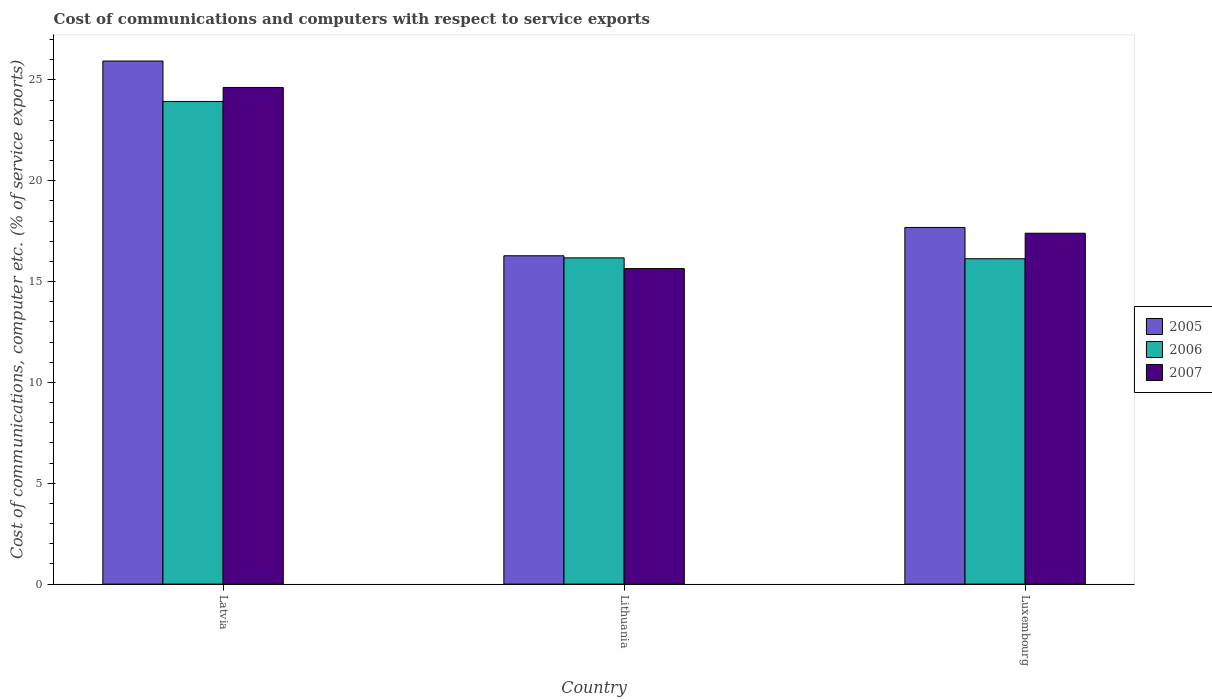Are the number of bars on each tick of the X-axis equal?
Ensure brevity in your answer.  Yes. How many bars are there on the 2nd tick from the left?
Your response must be concise. 3. What is the label of the 3rd group of bars from the left?
Provide a short and direct response. Luxembourg. In how many cases, is the number of bars for a given country not equal to the number of legend labels?
Offer a terse response. 0. What is the cost of communications and computers in 2005 in Latvia?
Your answer should be very brief. 25.94. Across all countries, what is the maximum cost of communications and computers in 2007?
Your answer should be very brief. 24.62. Across all countries, what is the minimum cost of communications and computers in 2007?
Your answer should be very brief. 15.64. In which country was the cost of communications and computers in 2006 maximum?
Your answer should be very brief. Latvia. In which country was the cost of communications and computers in 2005 minimum?
Your response must be concise. Lithuania. What is the total cost of communications and computers in 2006 in the graph?
Offer a very short reply. 56.24. What is the difference between the cost of communications and computers in 2007 in Latvia and that in Lithuania?
Make the answer very short. 8.98. What is the difference between the cost of communications and computers in 2006 in Latvia and the cost of communications and computers in 2007 in Lithuania?
Provide a short and direct response. 8.29. What is the average cost of communications and computers in 2005 per country?
Offer a very short reply. 19.97. What is the difference between the cost of communications and computers of/in 2006 and cost of communications and computers of/in 2005 in Latvia?
Your answer should be very brief. -2. In how many countries, is the cost of communications and computers in 2005 greater than 13 %?
Ensure brevity in your answer.  3. What is the ratio of the cost of communications and computers in 2007 in Lithuania to that in Luxembourg?
Offer a terse response. 0.9. What is the difference between the highest and the second highest cost of communications and computers in 2006?
Your answer should be compact. 0.04. What is the difference between the highest and the lowest cost of communications and computers in 2005?
Ensure brevity in your answer.  9.66. In how many countries, is the cost of communications and computers in 2006 greater than the average cost of communications and computers in 2006 taken over all countries?
Provide a succinct answer. 1. What does the 2nd bar from the right in Lithuania represents?
Ensure brevity in your answer.  2006. Is it the case that in every country, the sum of the cost of communications and computers in 2006 and cost of communications and computers in 2005 is greater than the cost of communications and computers in 2007?
Provide a short and direct response. Yes. What is the difference between two consecutive major ticks on the Y-axis?
Offer a terse response. 5. Are the values on the major ticks of Y-axis written in scientific E-notation?
Keep it short and to the point. No. Does the graph contain any zero values?
Your response must be concise. No. Does the graph contain grids?
Your response must be concise. No. Where does the legend appear in the graph?
Your answer should be compact. Center right. How many legend labels are there?
Provide a short and direct response. 3. How are the legend labels stacked?
Provide a succinct answer. Vertical. What is the title of the graph?
Offer a very short reply. Cost of communications and computers with respect to service exports. Does "1992" appear as one of the legend labels in the graph?
Ensure brevity in your answer.  No. What is the label or title of the X-axis?
Keep it short and to the point. Country. What is the label or title of the Y-axis?
Your answer should be compact. Cost of communications, computer etc. (% of service exports). What is the Cost of communications, computer etc. (% of service exports) in 2005 in Latvia?
Make the answer very short. 25.94. What is the Cost of communications, computer etc. (% of service exports) of 2006 in Latvia?
Offer a terse response. 23.93. What is the Cost of communications, computer etc. (% of service exports) in 2007 in Latvia?
Your response must be concise. 24.62. What is the Cost of communications, computer etc. (% of service exports) in 2005 in Lithuania?
Ensure brevity in your answer.  16.28. What is the Cost of communications, computer etc. (% of service exports) of 2006 in Lithuania?
Offer a very short reply. 16.18. What is the Cost of communications, computer etc. (% of service exports) in 2007 in Lithuania?
Offer a terse response. 15.64. What is the Cost of communications, computer etc. (% of service exports) in 2005 in Luxembourg?
Offer a very short reply. 17.68. What is the Cost of communications, computer etc. (% of service exports) of 2006 in Luxembourg?
Offer a very short reply. 16.13. What is the Cost of communications, computer etc. (% of service exports) in 2007 in Luxembourg?
Ensure brevity in your answer.  17.4. Across all countries, what is the maximum Cost of communications, computer etc. (% of service exports) in 2005?
Your answer should be very brief. 25.94. Across all countries, what is the maximum Cost of communications, computer etc. (% of service exports) of 2006?
Keep it short and to the point. 23.93. Across all countries, what is the maximum Cost of communications, computer etc. (% of service exports) in 2007?
Ensure brevity in your answer.  24.62. Across all countries, what is the minimum Cost of communications, computer etc. (% of service exports) in 2005?
Ensure brevity in your answer.  16.28. Across all countries, what is the minimum Cost of communications, computer etc. (% of service exports) in 2006?
Make the answer very short. 16.13. Across all countries, what is the minimum Cost of communications, computer etc. (% of service exports) of 2007?
Make the answer very short. 15.64. What is the total Cost of communications, computer etc. (% of service exports) of 2005 in the graph?
Give a very brief answer. 59.9. What is the total Cost of communications, computer etc. (% of service exports) of 2006 in the graph?
Offer a very short reply. 56.24. What is the total Cost of communications, computer etc. (% of service exports) in 2007 in the graph?
Give a very brief answer. 57.67. What is the difference between the Cost of communications, computer etc. (% of service exports) of 2005 in Latvia and that in Lithuania?
Offer a terse response. 9.66. What is the difference between the Cost of communications, computer etc. (% of service exports) of 2006 in Latvia and that in Lithuania?
Your answer should be compact. 7.76. What is the difference between the Cost of communications, computer etc. (% of service exports) in 2007 in Latvia and that in Lithuania?
Your answer should be compact. 8.98. What is the difference between the Cost of communications, computer etc. (% of service exports) in 2005 in Latvia and that in Luxembourg?
Ensure brevity in your answer.  8.25. What is the difference between the Cost of communications, computer etc. (% of service exports) of 2006 in Latvia and that in Luxembourg?
Ensure brevity in your answer.  7.8. What is the difference between the Cost of communications, computer etc. (% of service exports) in 2007 in Latvia and that in Luxembourg?
Your answer should be very brief. 7.23. What is the difference between the Cost of communications, computer etc. (% of service exports) in 2005 in Lithuania and that in Luxembourg?
Your answer should be very brief. -1.4. What is the difference between the Cost of communications, computer etc. (% of service exports) in 2006 in Lithuania and that in Luxembourg?
Provide a succinct answer. 0.04. What is the difference between the Cost of communications, computer etc. (% of service exports) in 2007 in Lithuania and that in Luxembourg?
Offer a very short reply. -1.75. What is the difference between the Cost of communications, computer etc. (% of service exports) of 2005 in Latvia and the Cost of communications, computer etc. (% of service exports) of 2006 in Lithuania?
Your response must be concise. 9.76. What is the difference between the Cost of communications, computer etc. (% of service exports) of 2005 in Latvia and the Cost of communications, computer etc. (% of service exports) of 2007 in Lithuania?
Provide a short and direct response. 10.29. What is the difference between the Cost of communications, computer etc. (% of service exports) in 2006 in Latvia and the Cost of communications, computer etc. (% of service exports) in 2007 in Lithuania?
Offer a terse response. 8.29. What is the difference between the Cost of communications, computer etc. (% of service exports) of 2005 in Latvia and the Cost of communications, computer etc. (% of service exports) of 2006 in Luxembourg?
Your answer should be very brief. 9.8. What is the difference between the Cost of communications, computer etc. (% of service exports) of 2005 in Latvia and the Cost of communications, computer etc. (% of service exports) of 2007 in Luxembourg?
Keep it short and to the point. 8.54. What is the difference between the Cost of communications, computer etc. (% of service exports) of 2006 in Latvia and the Cost of communications, computer etc. (% of service exports) of 2007 in Luxembourg?
Your answer should be compact. 6.53. What is the difference between the Cost of communications, computer etc. (% of service exports) of 2005 in Lithuania and the Cost of communications, computer etc. (% of service exports) of 2006 in Luxembourg?
Your response must be concise. 0.15. What is the difference between the Cost of communications, computer etc. (% of service exports) of 2005 in Lithuania and the Cost of communications, computer etc. (% of service exports) of 2007 in Luxembourg?
Keep it short and to the point. -1.12. What is the difference between the Cost of communications, computer etc. (% of service exports) of 2006 in Lithuania and the Cost of communications, computer etc. (% of service exports) of 2007 in Luxembourg?
Offer a very short reply. -1.22. What is the average Cost of communications, computer etc. (% of service exports) of 2005 per country?
Your response must be concise. 19.97. What is the average Cost of communications, computer etc. (% of service exports) of 2006 per country?
Give a very brief answer. 18.75. What is the average Cost of communications, computer etc. (% of service exports) of 2007 per country?
Your answer should be compact. 19.22. What is the difference between the Cost of communications, computer etc. (% of service exports) of 2005 and Cost of communications, computer etc. (% of service exports) of 2006 in Latvia?
Offer a terse response. 2. What is the difference between the Cost of communications, computer etc. (% of service exports) in 2005 and Cost of communications, computer etc. (% of service exports) in 2007 in Latvia?
Offer a terse response. 1.31. What is the difference between the Cost of communications, computer etc. (% of service exports) in 2006 and Cost of communications, computer etc. (% of service exports) in 2007 in Latvia?
Your answer should be compact. -0.69. What is the difference between the Cost of communications, computer etc. (% of service exports) of 2005 and Cost of communications, computer etc. (% of service exports) of 2006 in Lithuania?
Provide a short and direct response. 0.1. What is the difference between the Cost of communications, computer etc. (% of service exports) in 2005 and Cost of communications, computer etc. (% of service exports) in 2007 in Lithuania?
Give a very brief answer. 0.64. What is the difference between the Cost of communications, computer etc. (% of service exports) of 2006 and Cost of communications, computer etc. (% of service exports) of 2007 in Lithuania?
Ensure brevity in your answer.  0.53. What is the difference between the Cost of communications, computer etc. (% of service exports) of 2005 and Cost of communications, computer etc. (% of service exports) of 2006 in Luxembourg?
Provide a succinct answer. 1.55. What is the difference between the Cost of communications, computer etc. (% of service exports) of 2005 and Cost of communications, computer etc. (% of service exports) of 2007 in Luxembourg?
Offer a very short reply. 0.29. What is the difference between the Cost of communications, computer etc. (% of service exports) in 2006 and Cost of communications, computer etc. (% of service exports) in 2007 in Luxembourg?
Ensure brevity in your answer.  -1.26. What is the ratio of the Cost of communications, computer etc. (% of service exports) in 2005 in Latvia to that in Lithuania?
Ensure brevity in your answer.  1.59. What is the ratio of the Cost of communications, computer etc. (% of service exports) of 2006 in Latvia to that in Lithuania?
Your answer should be compact. 1.48. What is the ratio of the Cost of communications, computer etc. (% of service exports) of 2007 in Latvia to that in Lithuania?
Ensure brevity in your answer.  1.57. What is the ratio of the Cost of communications, computer etc. (% of service exports) of 2005 in Latvia to that in Luxembourg?
Offer a very short reply. 1.47. What is the ratio of the Cost of communications, computer etc. (% of service exports) of 2006 in Latvia to that in Luxembourg?
Provide a short and direct response. 1.48. What is the ratio of the Cost of communications, computer etc. (% of service exports) of 2007 in Latvia to that in Luxembourg?
Make the answer very short. 1.42. What is the ratio of the Cost of communications, computer etc. (% of service exports) of 2005 in Lithuania to that in Luxembourg?
Give a very brief answer. 0.92. What is the ratio of the Cost of communications, computer etc. (% of service exports) in 2007 in Lithuania to that in Luxembourg?
Provide a short and direct response. 0.9. What is the difference between the highest and the second highest Cost of communications, computer etc. (% of service exports) of 2005?
Make the answer very short. 8.25. What is the difference between the highest and the second highest Cost of communications, computer etc. (% of service exports) of 2006?
Keep it short and to the point. 7.76. What is the difference between the highest and the second highest Cost of communications, computer etc. (% of service exports) of 2007?
Make the answer very short. 7.23. What is the difference between the highest and the lowest Cost of communications, computer etc. (% of service exports) of 2005?
Make the answer very short. 9.66. What is the difference between the highest and the lowest Cost of communications, computer etc. (% of service exports) of 2006?
Give a very brief answer. 7.8. What is the difference between the highest and the lowest Cost of communications, computer etc. (% of service exports) in 2007?
Ensure brevity in your answer.  8.98. 